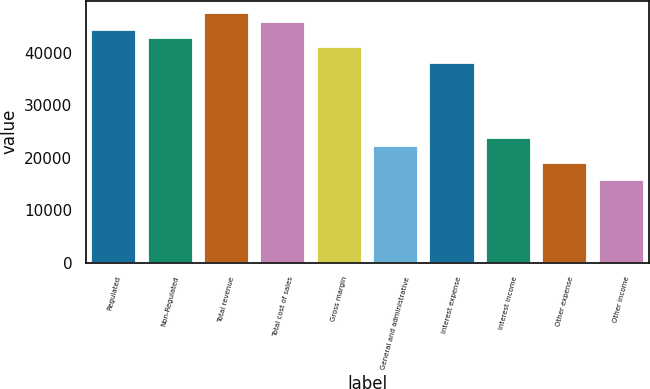Convert chart. <chart><loc_0><loc_0><loc_500><loc_500><bar_chart><fcel>Regulated<fcel>Non-Regulated<fcel>Total revenue<fcel>Total cost of sales<fcel>Gross margin<fcel>General and administrative<fcel>Interest expense<fcel>Interest income<fcel>Other expense<fcel>Other income<nl><fcel>44318.4<fcel>42735.6<fcel>47484<fcel>45901.2<fcel>41152.8<fcel>22159.2<fcel>37987.2<fcel>23742<fcel>18993.6<fcel>15828<nl></chart> 